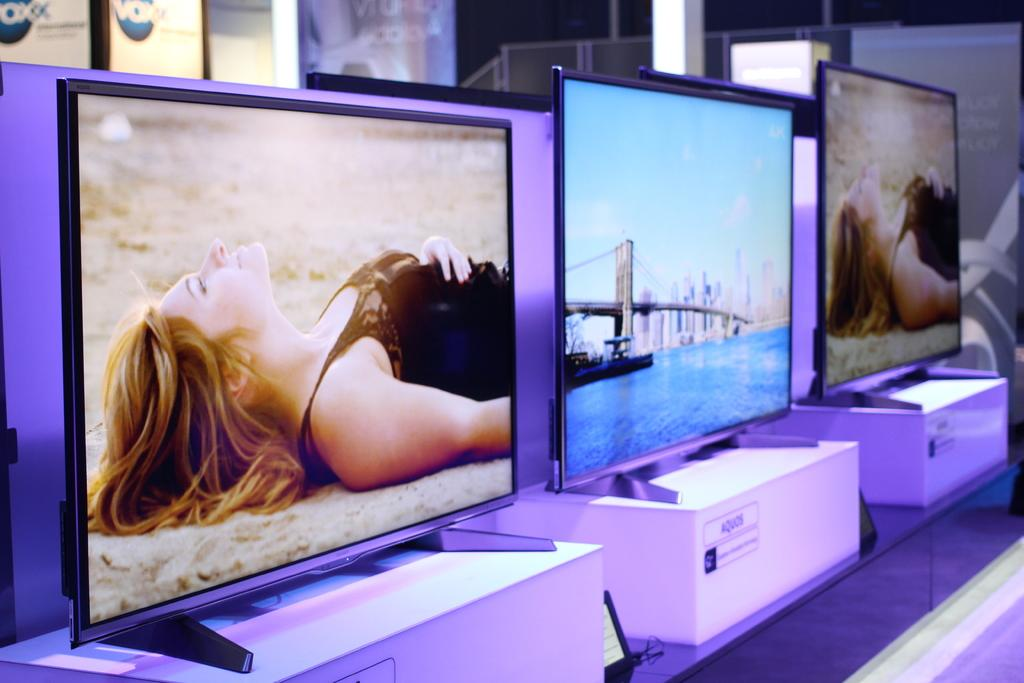<image>
Write a terse but informative summary of the picture. Three televisions in a row with the brand name aquos. 